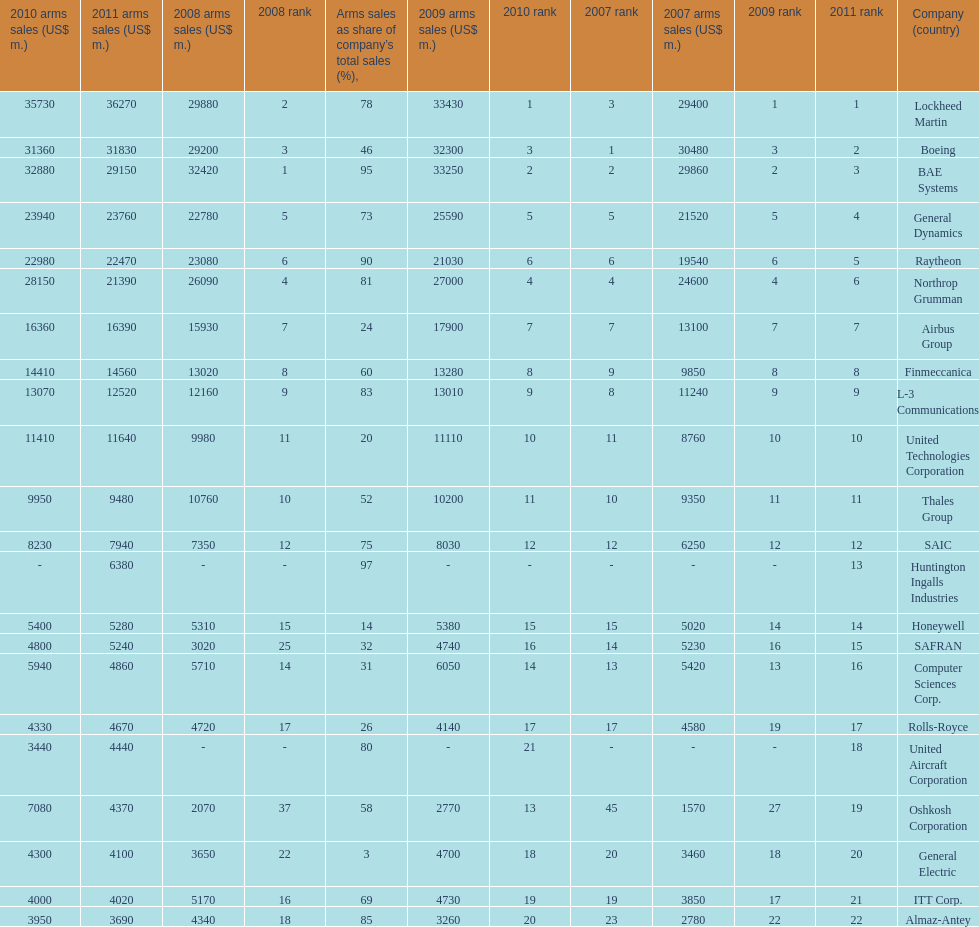In 2010, who has the least amount of sales? United Aircraft Corporation. 